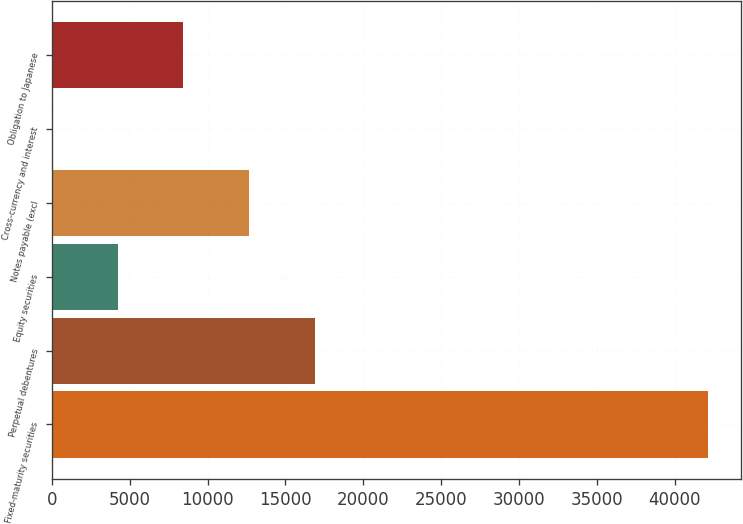<chart> <loc_0><loc_0><loc_500><loc_500><bar_chart><fcel>Fixed-maturity securities<fcel>Perpetual debentures<fcel>Equity securities<fcel>Notes payable (excl<fcel>Cross-currency and interest<fcel>Obligation to Japanese<nl><fcel>42174<fcel>16873.8<fcel>4223.7<fcel>12657.1<fcel>7<fcel>8440.4<nl></chart> 